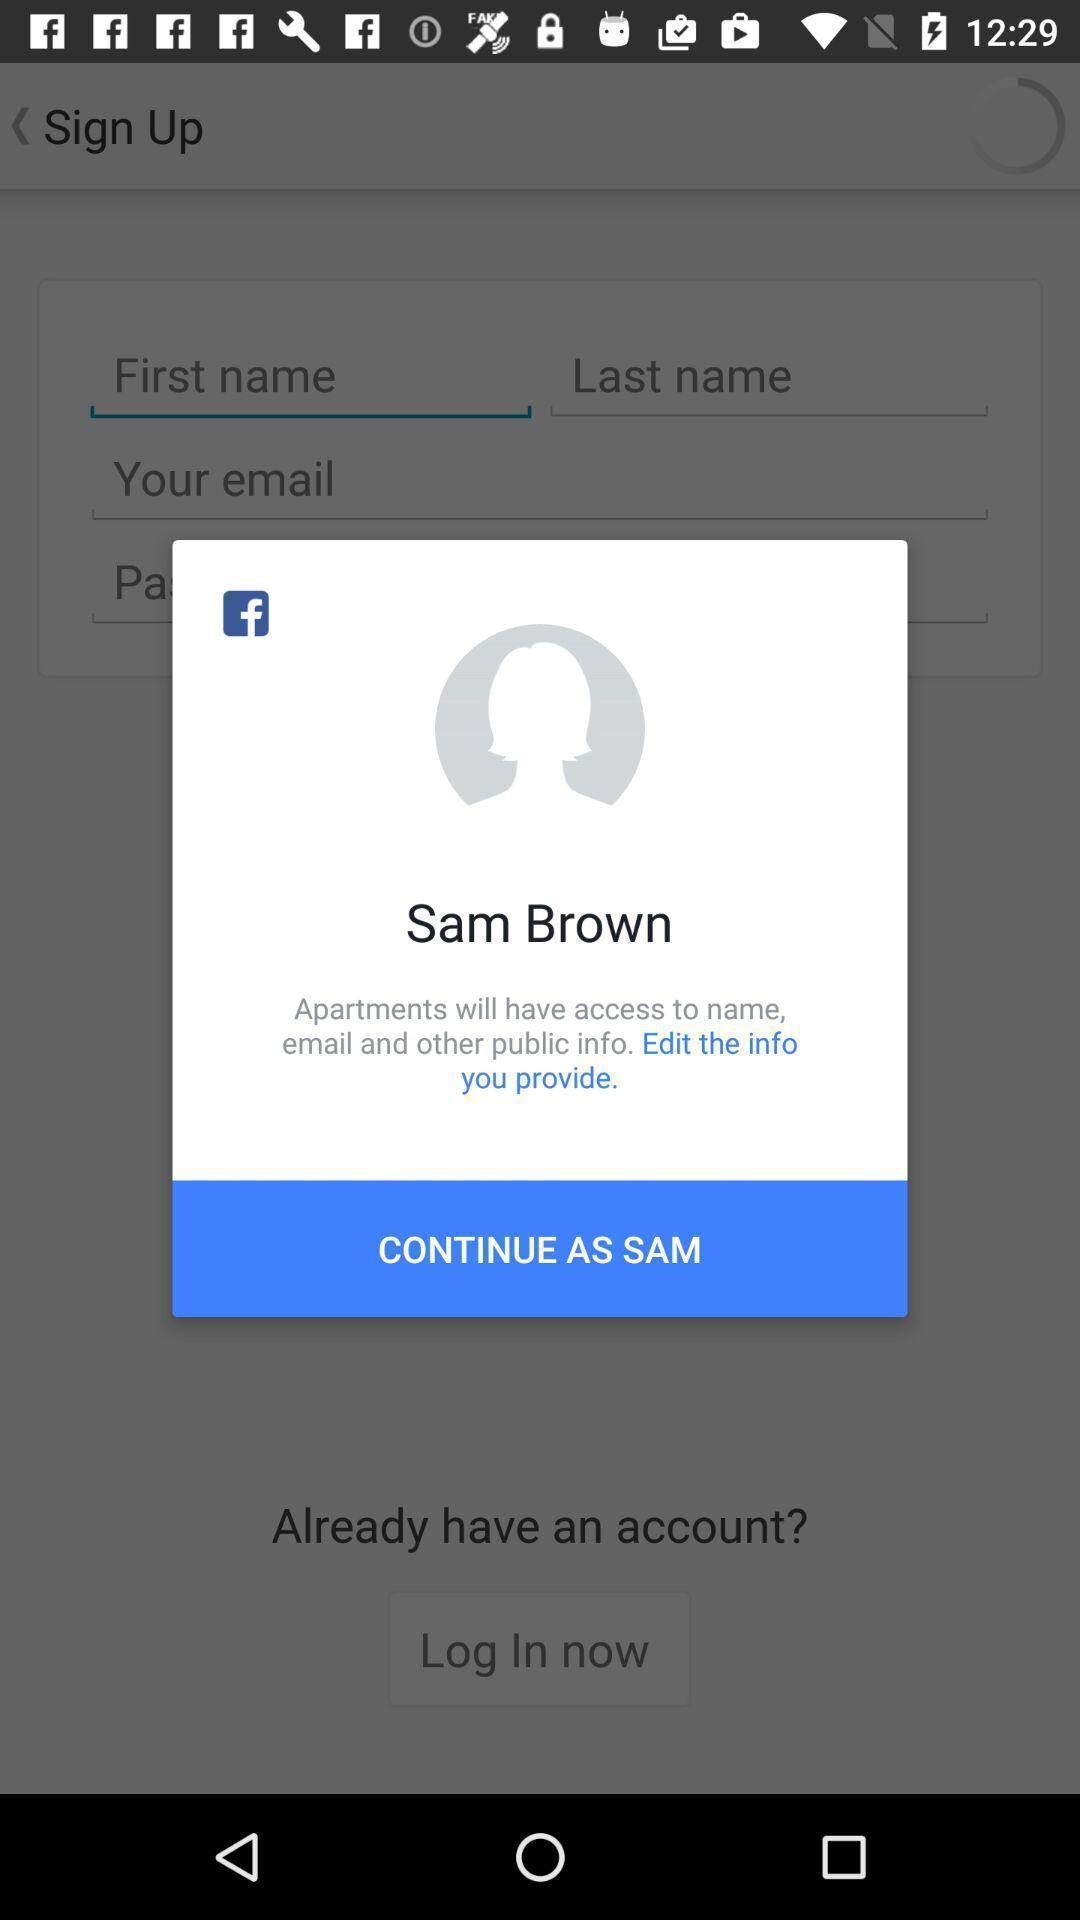What can you discern from this picture? Screen shows continue option with a social app. 